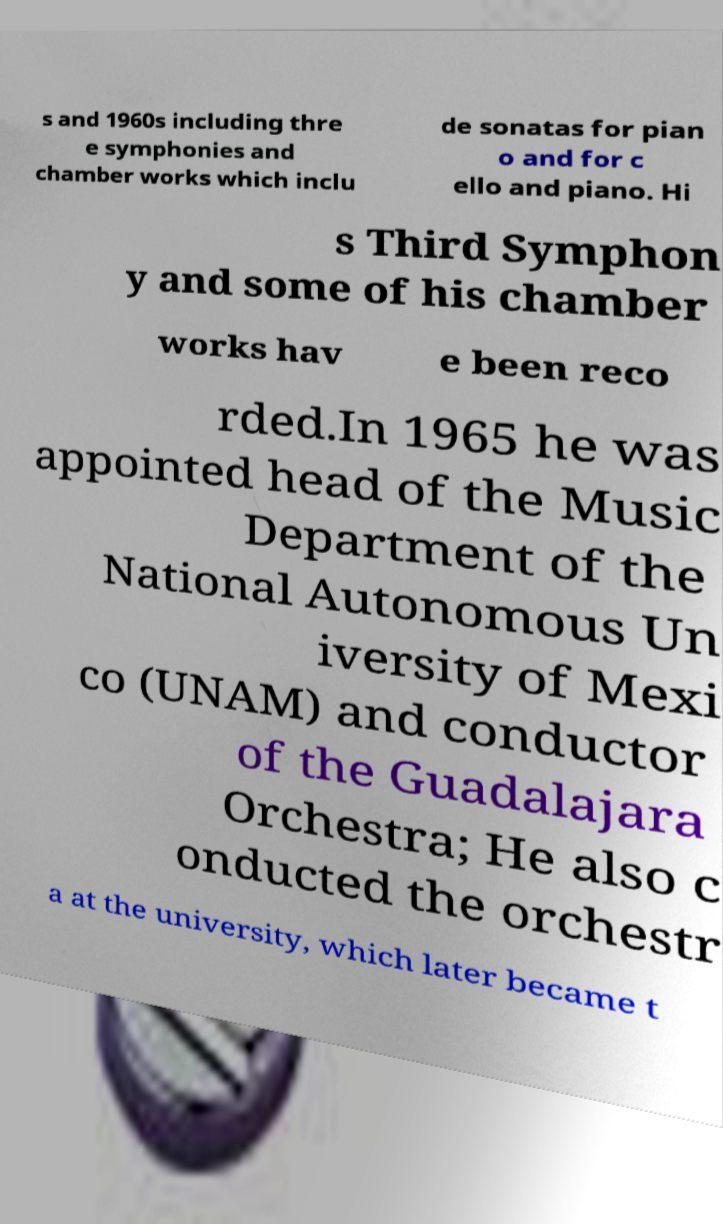Please identify and transcribe the text found in this image. s and 1960s including thre e symphonies and chamber works which inclu de sonatas for pian o and for c ello and piano. Hi s Third Symphon y and some of his chamber works hav e been reco rded.In 1965 he was appointed head of the Music Department of the National Autonomous Un iversity of Mexi co (UNAM) and conductor of the Guadalajara Orchestra; He also c onducted the orchestr a at the university, which later became t 